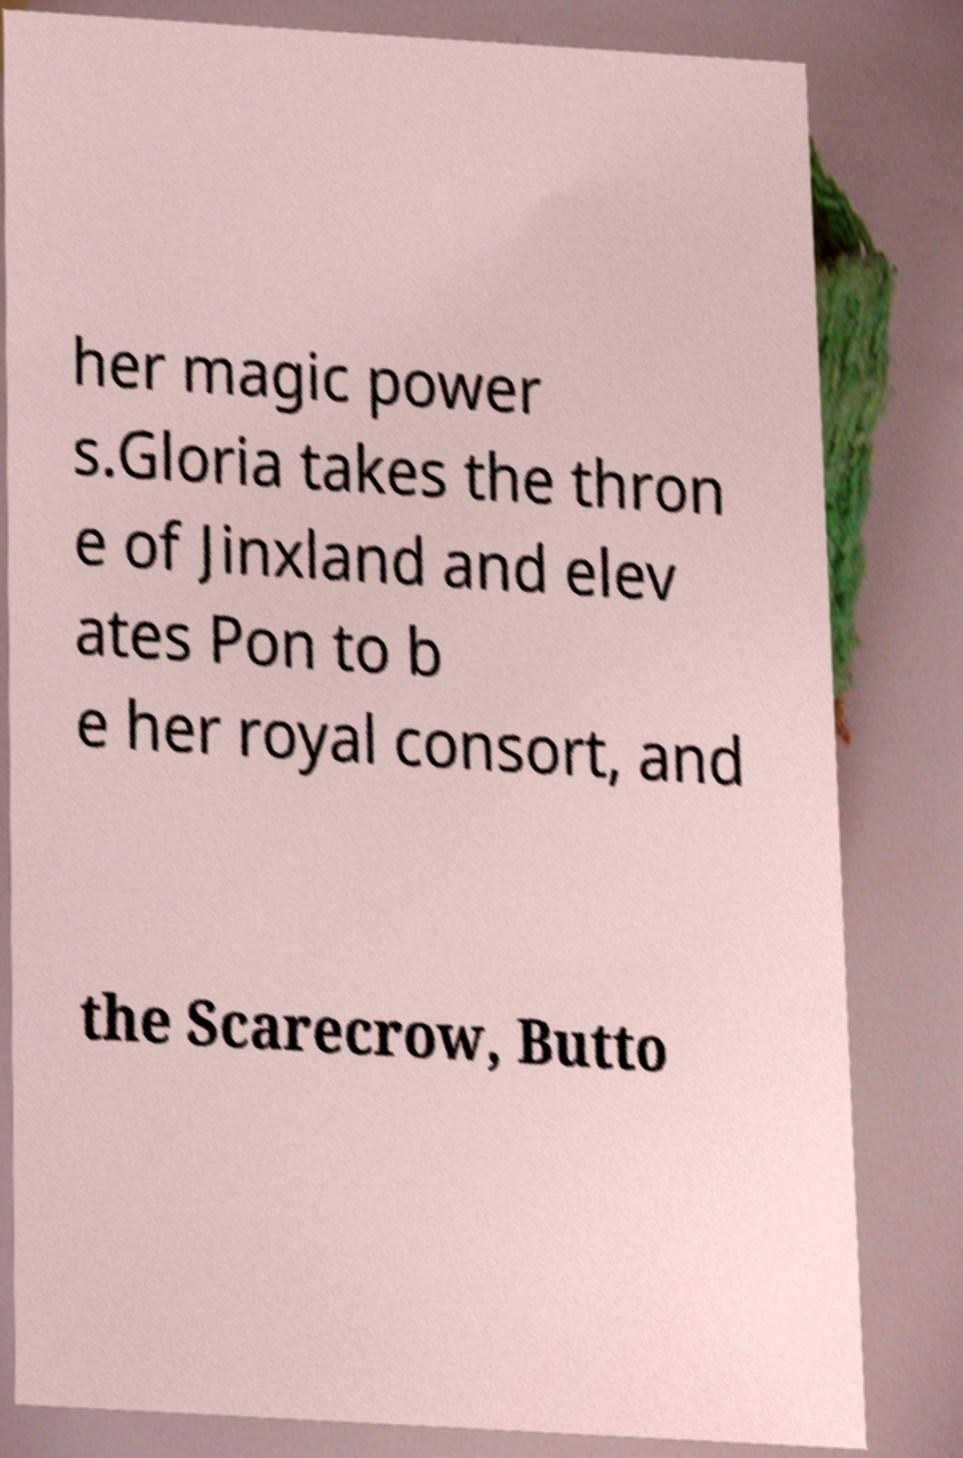Could you extract and type out the text from this image? her magic power s.Gloria takes the thron e of Jinxland and elev ates Pon to b e her royal consort, and the Scarecrow, Butto 